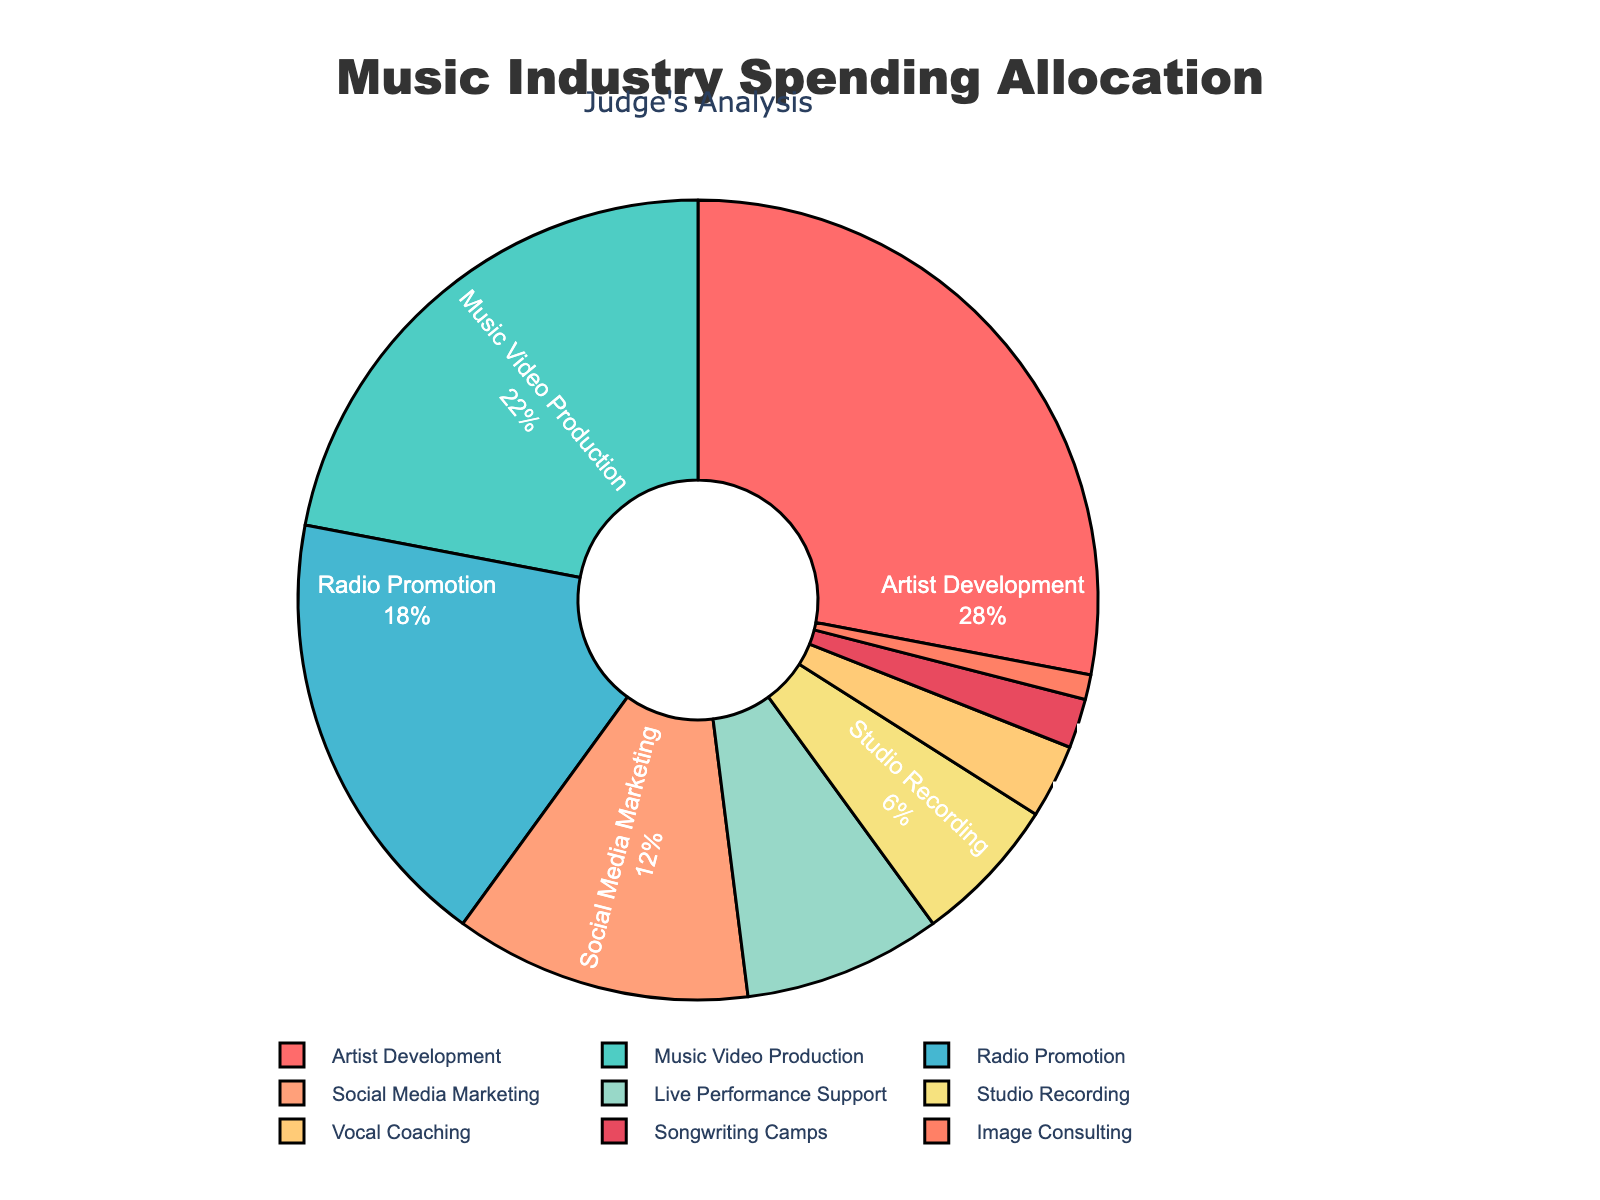What's the percentage of spending on Social Media Marketing and Live Performance Support combined? To find the combined percentage of spending on Social Media Marketing and Live Performance Support, add the percentages from each category. Social Media Marketing: 12%, Live Performance Support: 8%. The combined total is 12% + 8% = 20%
Answer: 20% Which category has the highest allocation of spending? By examining the percentages in the pie chart, the category with the highest allocation of spending is Artist Development with 28%.
Answer: Artist Development Which category has a larger allocation of spending: Music Video Production or Radio Promotion? Compare the percentages for Music Video Production (22%) and Radio Promotion (18%) given on the pie chart. Music Video Production has a larger allocation at 22%.
Answer: Music Video Production What is the difference in allocation between the category with the highest spending and the category with the lowest spending? The category with the highest spending is Artist Development at 28%, and the category with the lowest spending is Image Consulting at 1%. The difference is 28% - 1% = 27%
Answer: 27% What is the total percentage of spending on categories that support live performances and artist image, including Live Performance Support, Vocal Coaching, and Image Consulting? Add the percentages of the categories that contribute to live performances and artist image. Live Performance Support: 8%, Vocal Coaching: 3%, Image Consulting: 1%. The combined total is 8% + 3% + 1% = 12%
Answer: 12% How does the spending on Vocal Coaching compare to that on Studio Recording? From the pie chart, Vocal Coaching has a spending allocation of 3%, and Studio Recording has 6%. Studio Recording has a higher allocation compared to Vocal Coaching.
Answer: Studio Recording What percentage of the budget is allocated to both Songwriting Camps and Image Consulting together? Combine the percentages for Songwriting Camps (2%) and Image Consulting (1%). The total percentage is 2% + 1% = 3%
Answer: 3% What proportion of the total budget is allocated to artist-centric development categories (Artist Development and Vocal Coaching)? To find the proportion of the total budget allocated to artist-centric development categories, add the percentages for Artist Development (28%) and Vocal Coaching (3%). The total is 28% + 3% = 31%
Answer: 31% Which segment appears green, and what percentage of the budget is allocated to it? By looking at the color-coded pie chart, the segment that appears green is Radio Promotion with an allocation of 18%.
Answer: Radio Promotion What is the combined percentage of spending on Artist Development, Music Video Production, and Radio Promotion? To find the combined percentage, add the percentages for Artist Development (28%), Music Video Production (22%), and Radio Promotion (18%). The total is 28% + 22% + 18% = 68%
Answer: 68% 